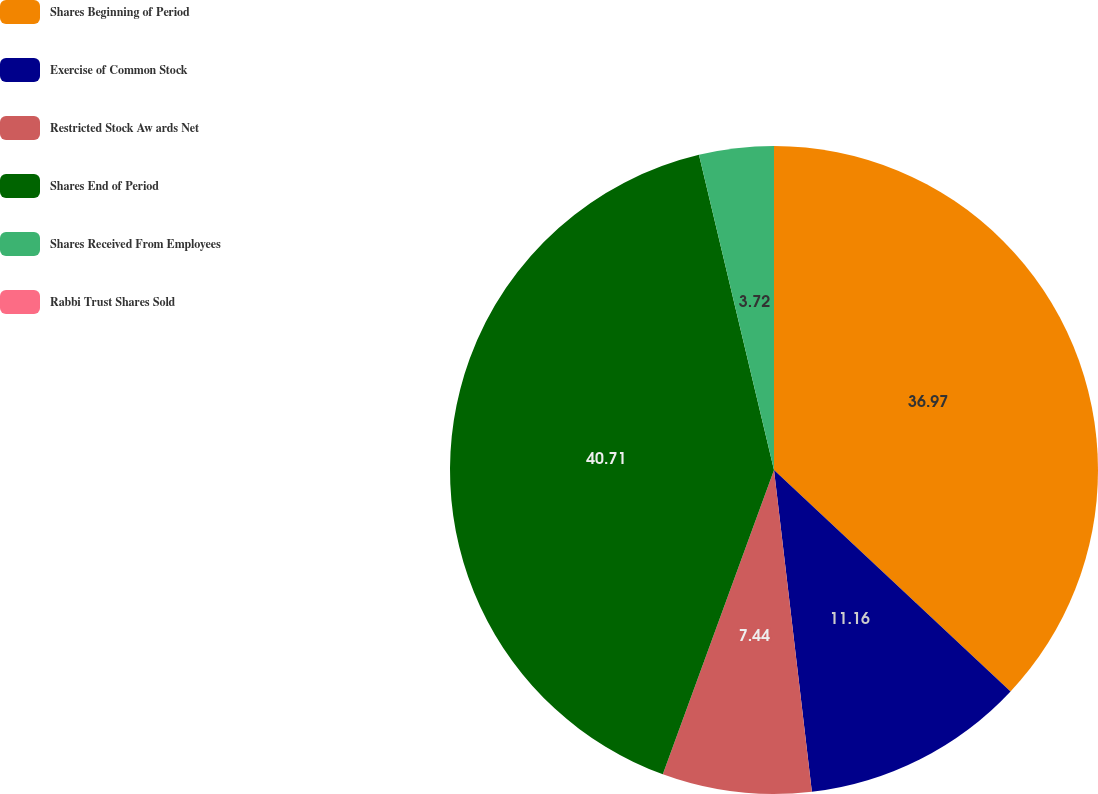Convert chart. <chart><loc_0><loc_0><loc_500><loc_500><pie_chart><fcel>Shares Beginning of Period<fcel>Exercise of Common Stock<fcel>Restricted Stock Aw ards Net<fcel>Shares End of Period<fcel>Shares Received From Employees<fcel>Rabbi Trust Shares Sold<nl><fcel>36.97%<fcel>11.16%<fcel>7.44%<fcel>40.7%<fcel>3.72%<fcel>0.0%<nl></chart> 